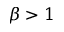<formula> <loc_0><loc_0><loc_500><loc_500>\beta > 1</formula> 